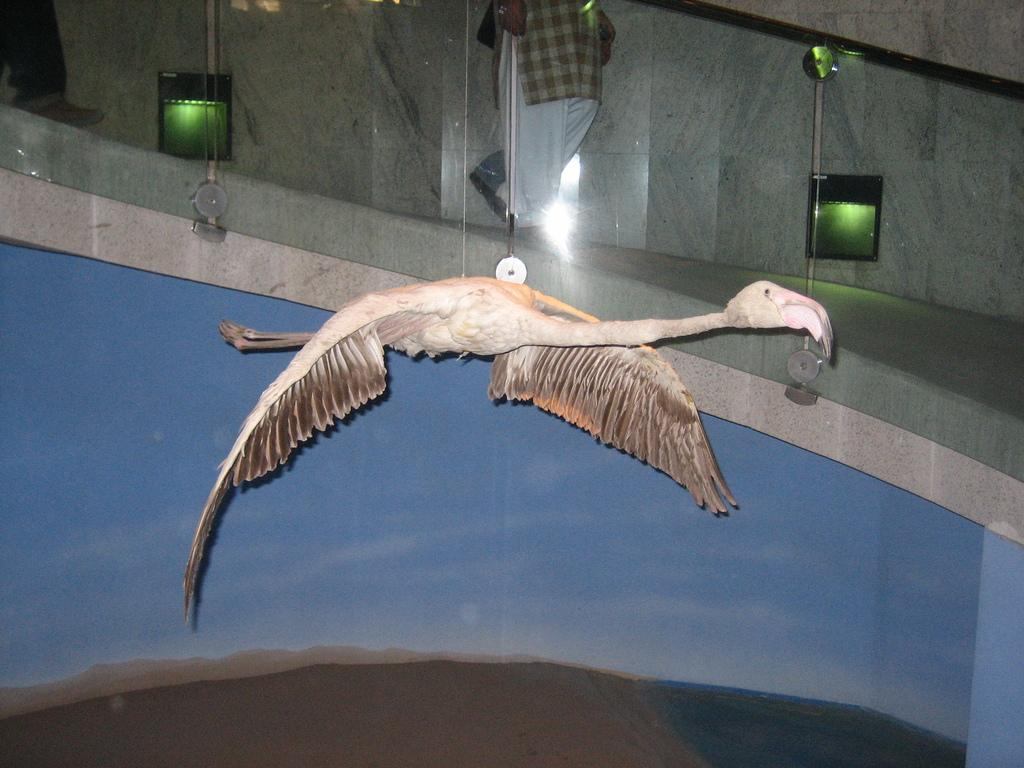What type of bird is present in the image? There is an artificial bird in the image. How is the bird positioned in the image? The bird is hanging. What can be seen in the background of the image? There is a wall, a glass railing, lights, and a person in the background of the image. How many eggs are being held by the person in the image? There is no person holding eggs in the image. The person in the background is not holding any visible objects. 